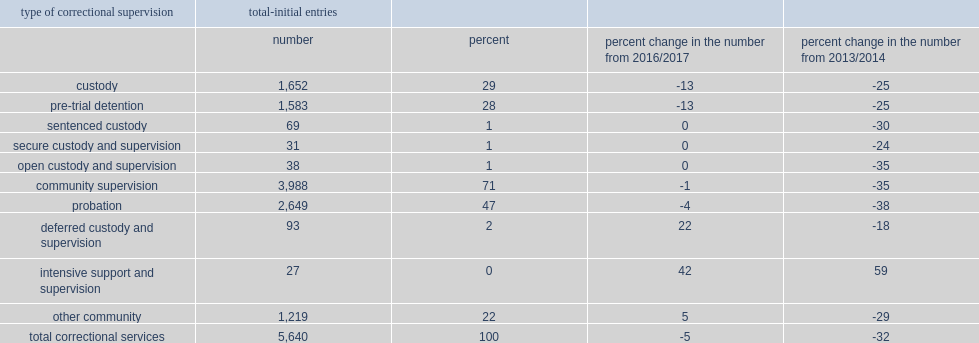How many youth were there that began a period of supervision in correctional services in 2017/2018? 5640.0. What was the declines in the rate of youth that began a period of supervision in correctional services from 2016/2017? 5. What was the declines in the rate of youth that began a period of supervision in correctional services from 2013/2014? 32. What was the proportion of initial entries were to community supervision in 2017/2018? 71.0. How much did the rate of initial entries were to community supervision decrease from 2016/2017? 1. What is the percentage of of all initial entries were primarily entering a period of probation in 2017/2018? 47.0. What is the percentage of of all initial entries were under other community supervision in 2017/2018? 22.0. What is the percentage of initial entries for youth in the reporting jurisdictions in 2017/2018 were into custody? 29.0. What is the percentage of initial entries for youth in the reporting jurisdictions in 2017/2018 were into pre-trial detention? 28.0. How much did the rate of initial entries for youth were into custody decrease from the 2016/2017? 13. How much did the rate of initial entries for youth were into custody decrease from the 2013/2014? 25. 